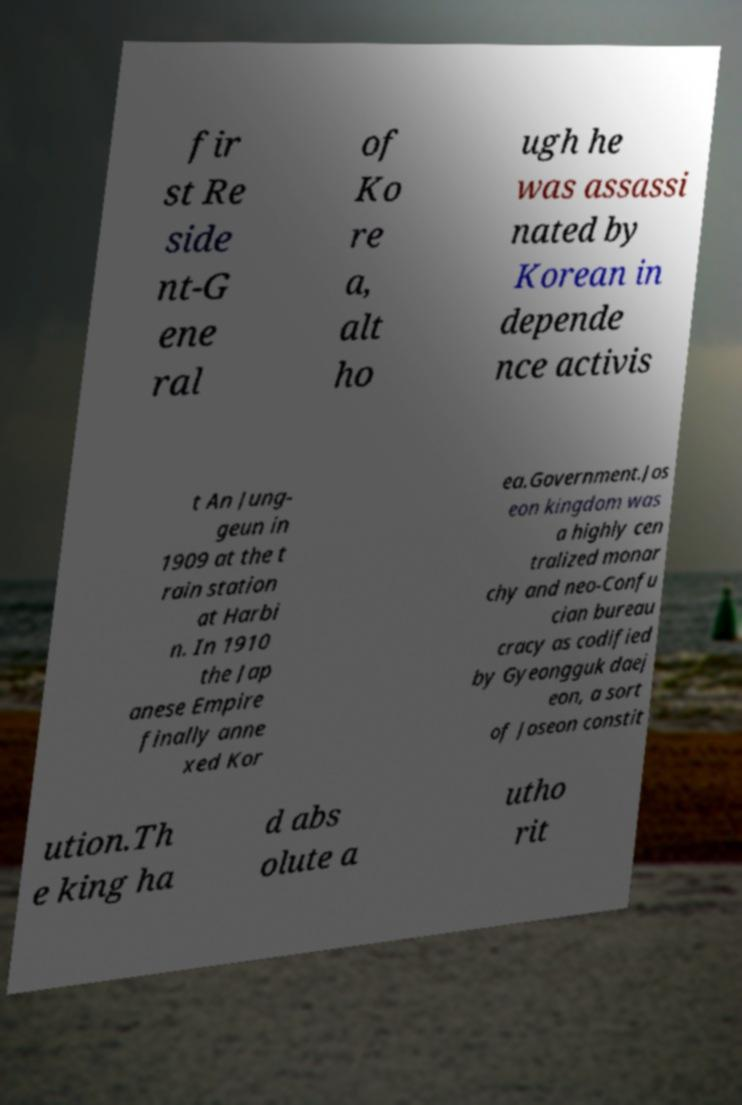I need the written content from this picture converted into text. Can you do that? fir st Re side nt-G ene ral of Ko re a, alt ho ugh he was assassi nated by Korean in depende nce activis t An Jung- geun in 1909 at the t rain station at Harbi n. In 1910 the Jap anese Empire finally anne xed Kor ea.Government.Jos eon kingdom was a highly cen tralized monar chy and neo-Confu cian bureau cracy as codified by Gyeongguk daej eon, a sort of Joseon constit ution.Th e king ha d abs olute a utho rit 